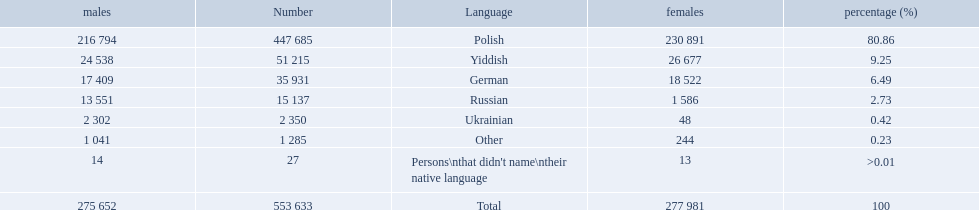Which language options are listed? Polish, Yiddish, German, Russian, Ukrainian, Other, Persons\nthat didn't name\ntheir native language. Of these, which did .42% of the people select? Ukrainian. 